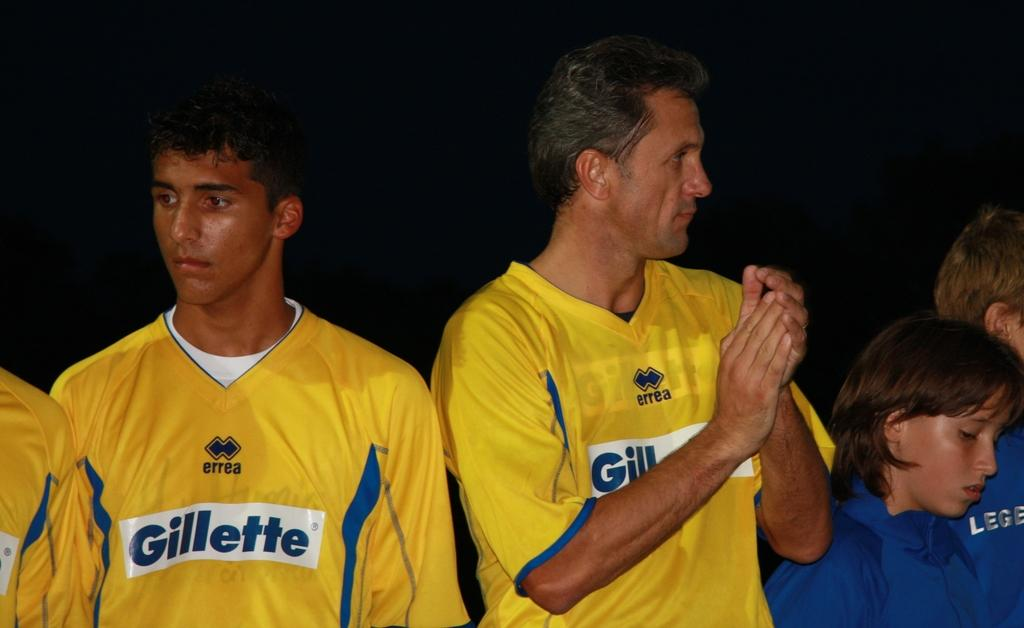<image>
Write a terse but informative summary of the picture. the yellow team has jersey with word Gillette in the front 